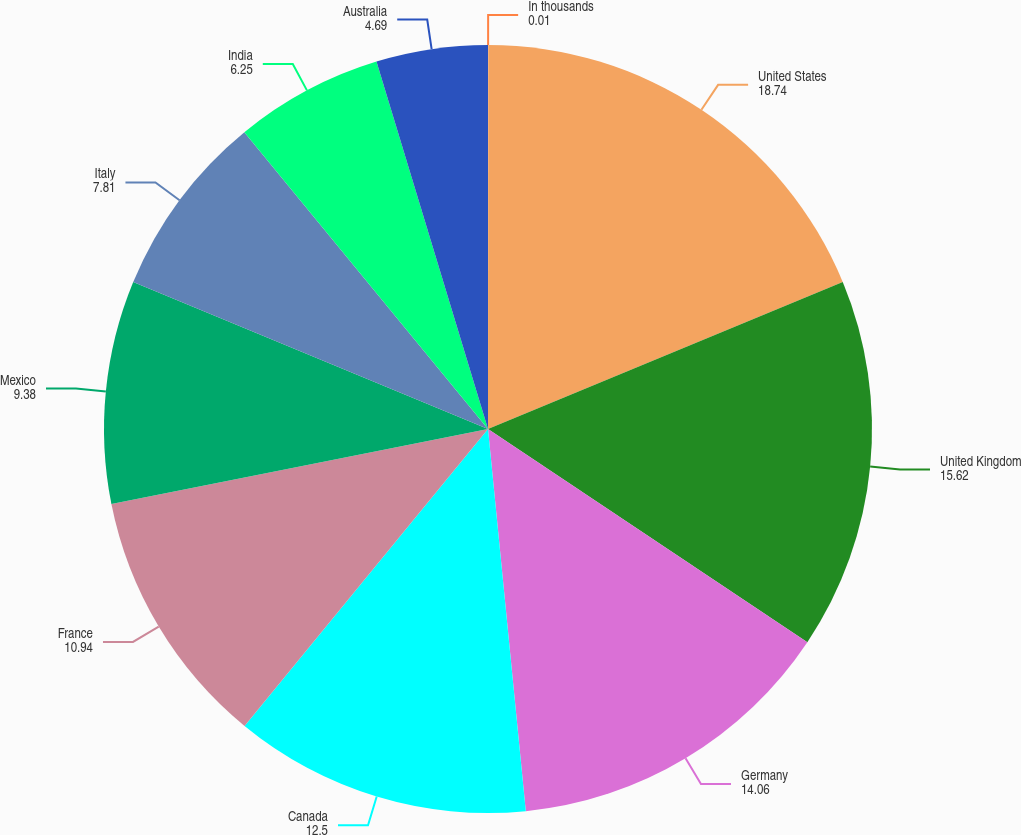<chart> <loc_0><loc_0><loc_500><loc_500><pie_chart><fcel>In thousands<fcel>United States<fcel>United Kingdom<fcel>Germany<fcel>Canada<fcel>France<fcel>Mexico<fcel>Italy<fcel>India<fcel>Australia<nl><fcel>0.01%<fcel>18.74%<fcel>15.62%<fcel>14.06%<fcel>12.5%<fcel>10.94%<fcel>9.38%<fcel>7.81%<fcel>6.25%<fcel>4.69%<nl></chart> 